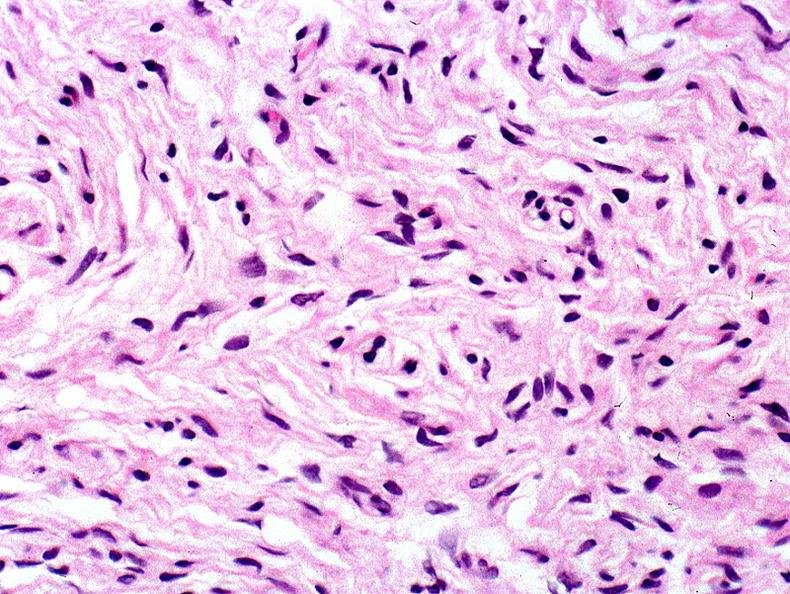does marfans syndrome show skin, neurofibromatosis?
Answer the question using a single word or phrase. No 